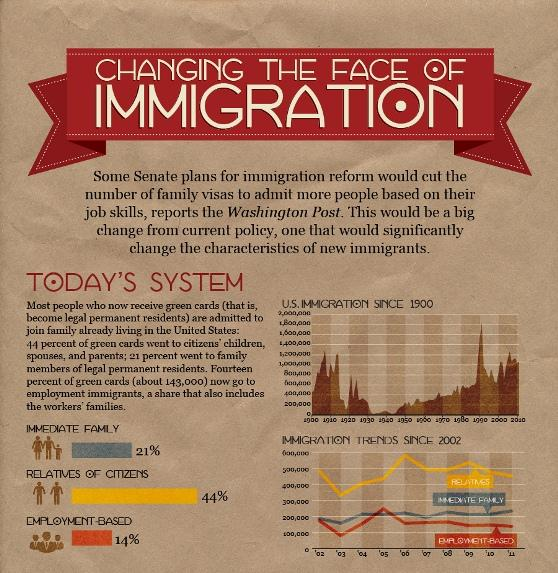Outline some significant characteristics in this image. The color code for "Employment-Based" is red, grey, orange, and yellow. Specifically, the color code for "Employment-Based" is orange. The color code for "Relatives" is red, green, yellow, and orange. Specifically, the color code for "Relatives" is yellow. In the year 2003, the smallest number of immediate family members moved to America. The color code for the term 'Immediate Family' is red, grey, yellow, and orange, with grey being the primary color. In the year 2005, the highest number of people moved to America for their job. 